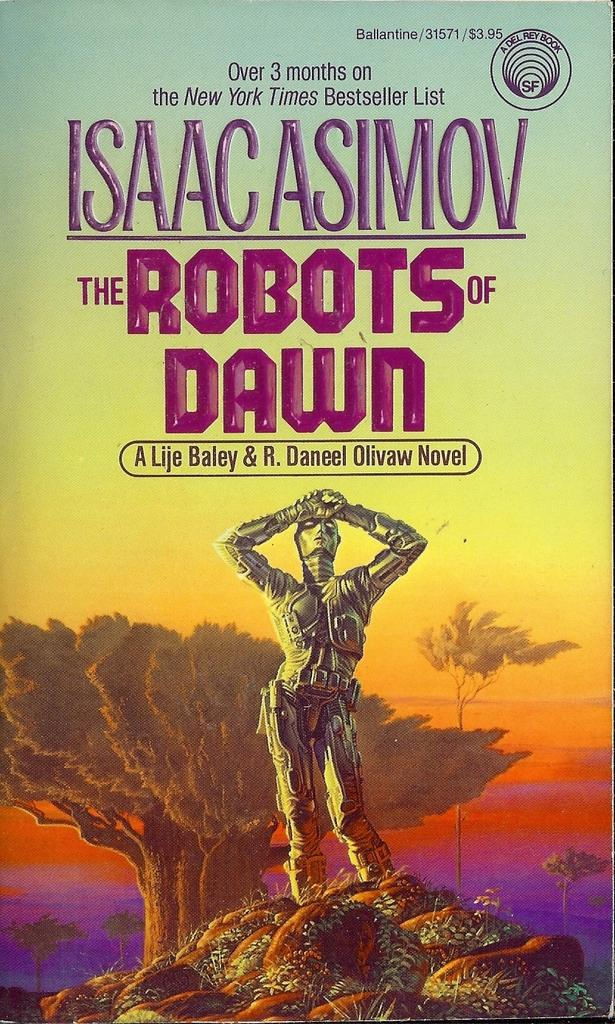<image>
Render a clear and concise summary of the photo. The book was titled The Robots Of Dawn. 